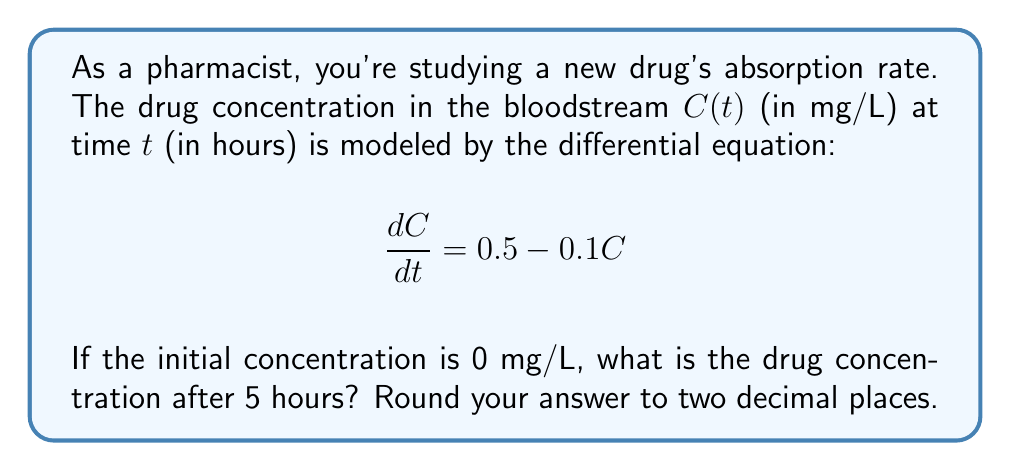Help me with this question. Let's solve this step-by-step:

1) The given differential equation is of the form:
   $$\frac{dC}{dt} + 0.1C = 0.5$$

2) This is a first-order linear differential equation. The general solution is:
   $$C(t) = Ce^{-0.1t} + 5$$
   where $C$ is a constant to be determined.

3) Using the initial condition $C(0) = 0$:
   $$0 = C + 5$$
   $$C = -5$$

4) Therefore, the particular solution is:
   $$C(t) = 5(1 - e^{-0.1t})$$

5) To find the concentration after 5 hours, we substitute $t = 5$:
   $$C(5) = 5(1 - e^{-0.1(5)})$$
   $$C(5) = 5(1 - e^{-0.5})$$

6) Calculating this:
   $$C(5) = 5(1 - 0.6065)$$
   $$C(5) = 5(0.3935)$$
   $$C(5) = 1.9675$$

7) Rounding to two decimal places:
   $$C(5) \approx 1.97$$ mg/L
Answer: 1.97 mg/L 